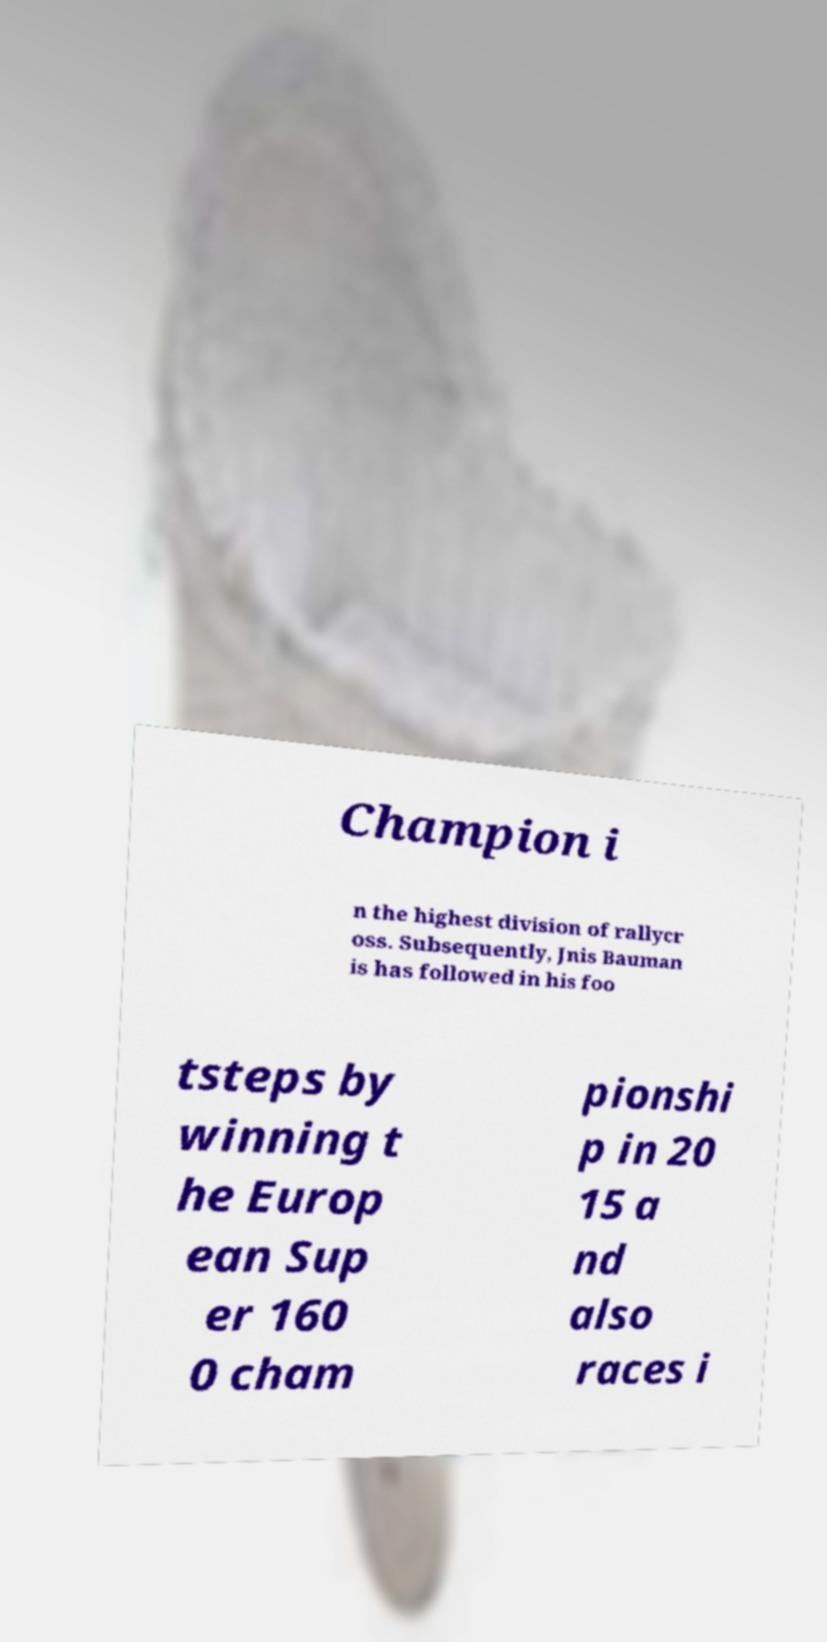What messages or text are displayed in this image? I need them in a readable, typed format. Champion i n the highest division of rallycr oss. Subsequently, Jnis Bauman is has followed in his foo tsteps by winning t he Europ ean Sup er 160 0 cham pionshi p in 20 15 a nd also races i 